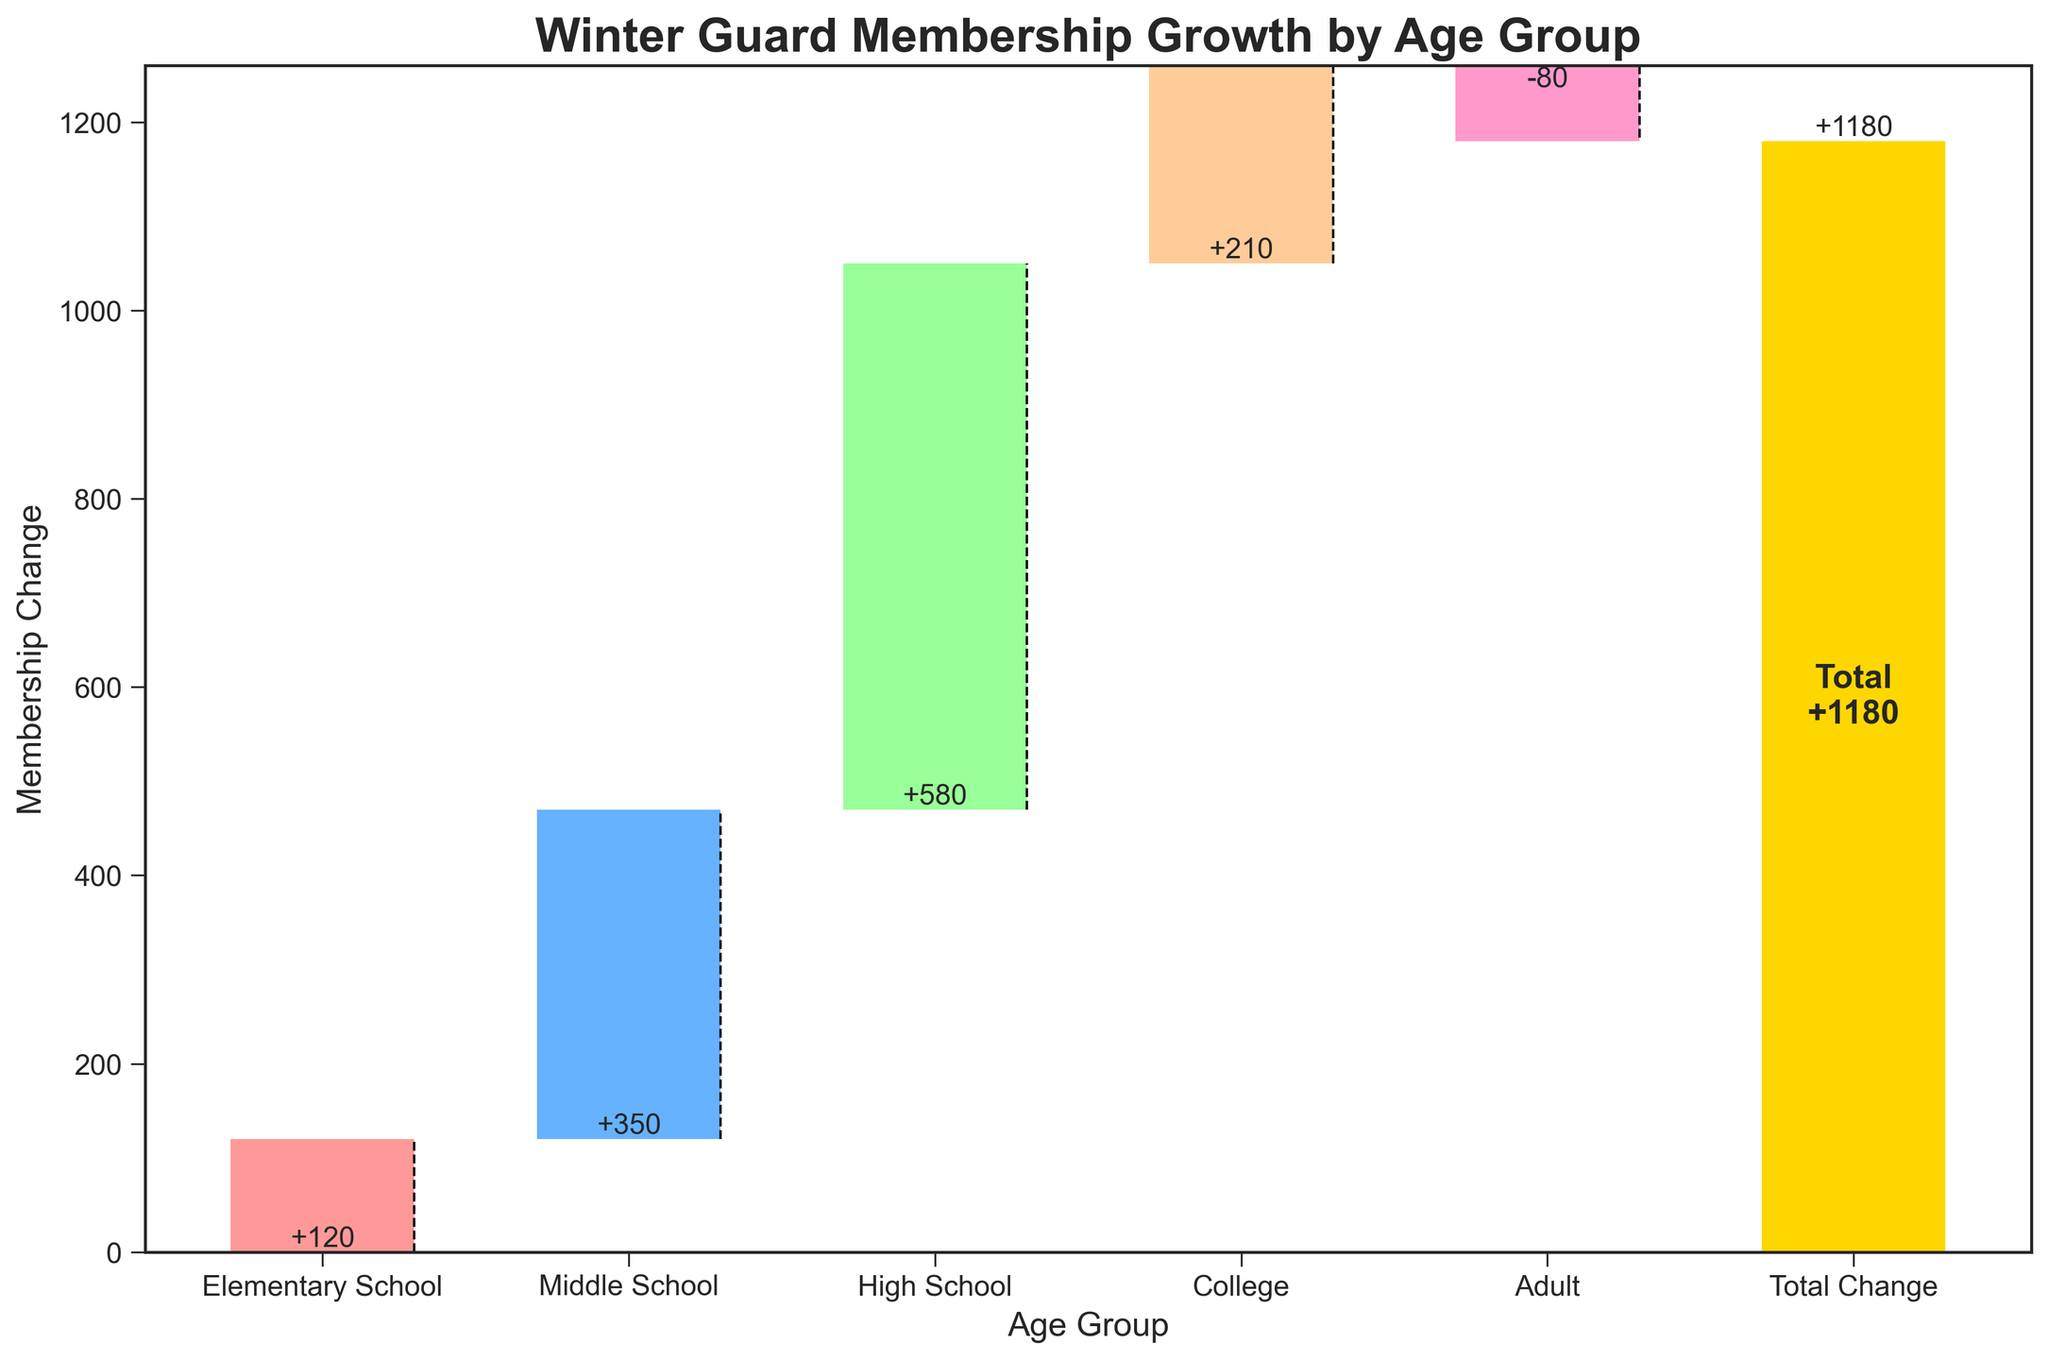What is the total change in membership across all age groups? To find the total change, look at the bar labeled "Total Change" in the plot. The value associated with this bar indicates the overall membership change over all the age groups combined.
Answer: 1180 Which age group saw the highest increase in membership? Examine the heights of the bars for each age group. The tallest bar represents the greatest increase in membership.
Answer: High School Did the Adult age group experience an increase or decrease in membership? Look at the bar for the "Adult" age group. If the bar goes downward from the baseline, it's a decrease; if it goes upward, it's an increase.
Answer: Decrease How much did the High School age group contribute to the total change in membership? Look at the value associated with the High School bar. The value represents the contribution of the High School age group to the total change in membership.
Answer: +580 What is the cumulative membership change up to and including the Middle School age group? Cumulatively add the membership changes for the Elementary School and Middle School age groups. (+120) + (+350) = 470
Answer: 470 How does the membership growth in the College age group compare to the Elementary School age group? Compare the heights of the bars for College and Elementary School. Determine which bar is taller to decide which group has a greater increase or if they experienced a decrease or smaller increase.
Answer: College saw higher growth How many age groups showed an increase in membership? Count the number of bars that extend upward from the baseline, excluding the "Total Change" bar. There are bars for Elementary School, Middle School, High School, and College that go upward indicating an increase.
Answer: 4 How does the change in the Middle School age group compare to the Adult age group? Compare the heights and directions of the bars for Middle School and Adult. The Middle School bar indicates an increase, while the Adult bar indicates a decrease.
Answer: Middle School had a greater increase What is the average membership change across the Elementary, Middle, and High School age groups? Add the changes in Elementary School (+120), Middle School (+350), and High School (+580) together and then divide by 3. (120 + 350 + 580) / 3 = 350
Answer: 350 Is there any age group that experienced a decrease in membership? Look for any bar that extends downward from the baseline. The Adult age group bar extends downward, indicating a decrease.
Answer: Yes 